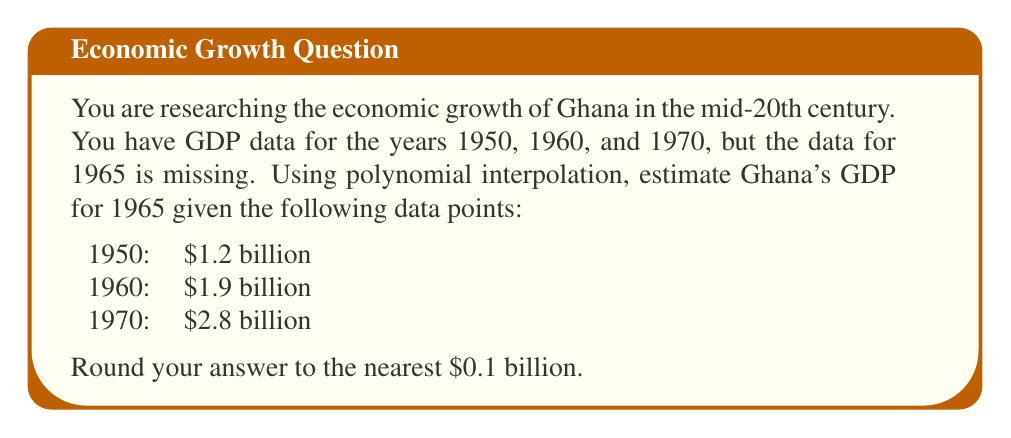Can you solve this math problem? To estimate the missing GDP data for 1965 using polynomial interpolation, we'll follow these steps:

1) First, we'll use a quadratic polynomial of the form $f(x) = ax^2 + bx + c$ to fit the given data points. Here, $x$ represents the number of years since 1950, and $f(x)$ represents the GDP in billions of dollars.

2) We have three data points:
   (0, 1.2), (10, 1.9), (20, 2.8)

3) Substituting these points into the quadratic equation:
   $1.2 = a(0)^2 + b(0) + c$
   $1.9 = a(10)^2 + b(10) + c$
   $2.8 = a(20)^2 + b(20) + c$

4) Simplifying:
   $1.2 = c$
   $1.9 = 100a + 10b + 1.2$
   $2.8 = 400a + 20b + 1.2$

5) From the first equation, $c = 1.2$. Subtracting this from the other two equations:
   $0.7 = 100a + 10b$
   $1.6 = 400a + 20b$

6) Multiplying the first equation by 2 and subtracting from the second:
   $1.4 = 100a + 20b$
   $0.2 = 200a$

7) Solving for $a$ and $b$:
   $a = 0.001$
   $b = 0.06$

8) Our interpolation polynomial is thus:
   $f(x) = 0.001x^2 + 0.06x + 1.2$

9) To estimate the GDP for 1965, we calculate $f(15)$:
   $f(15) = 0.001(15)^2 + 0.06(15) + 1.2$
   $= 0.225 + 0.9 + 1.2$
   $= 2.325$

10) Rounding to the nearest $0.1 billion, we get $2.3 billion.
Answer: $2.3 billion 